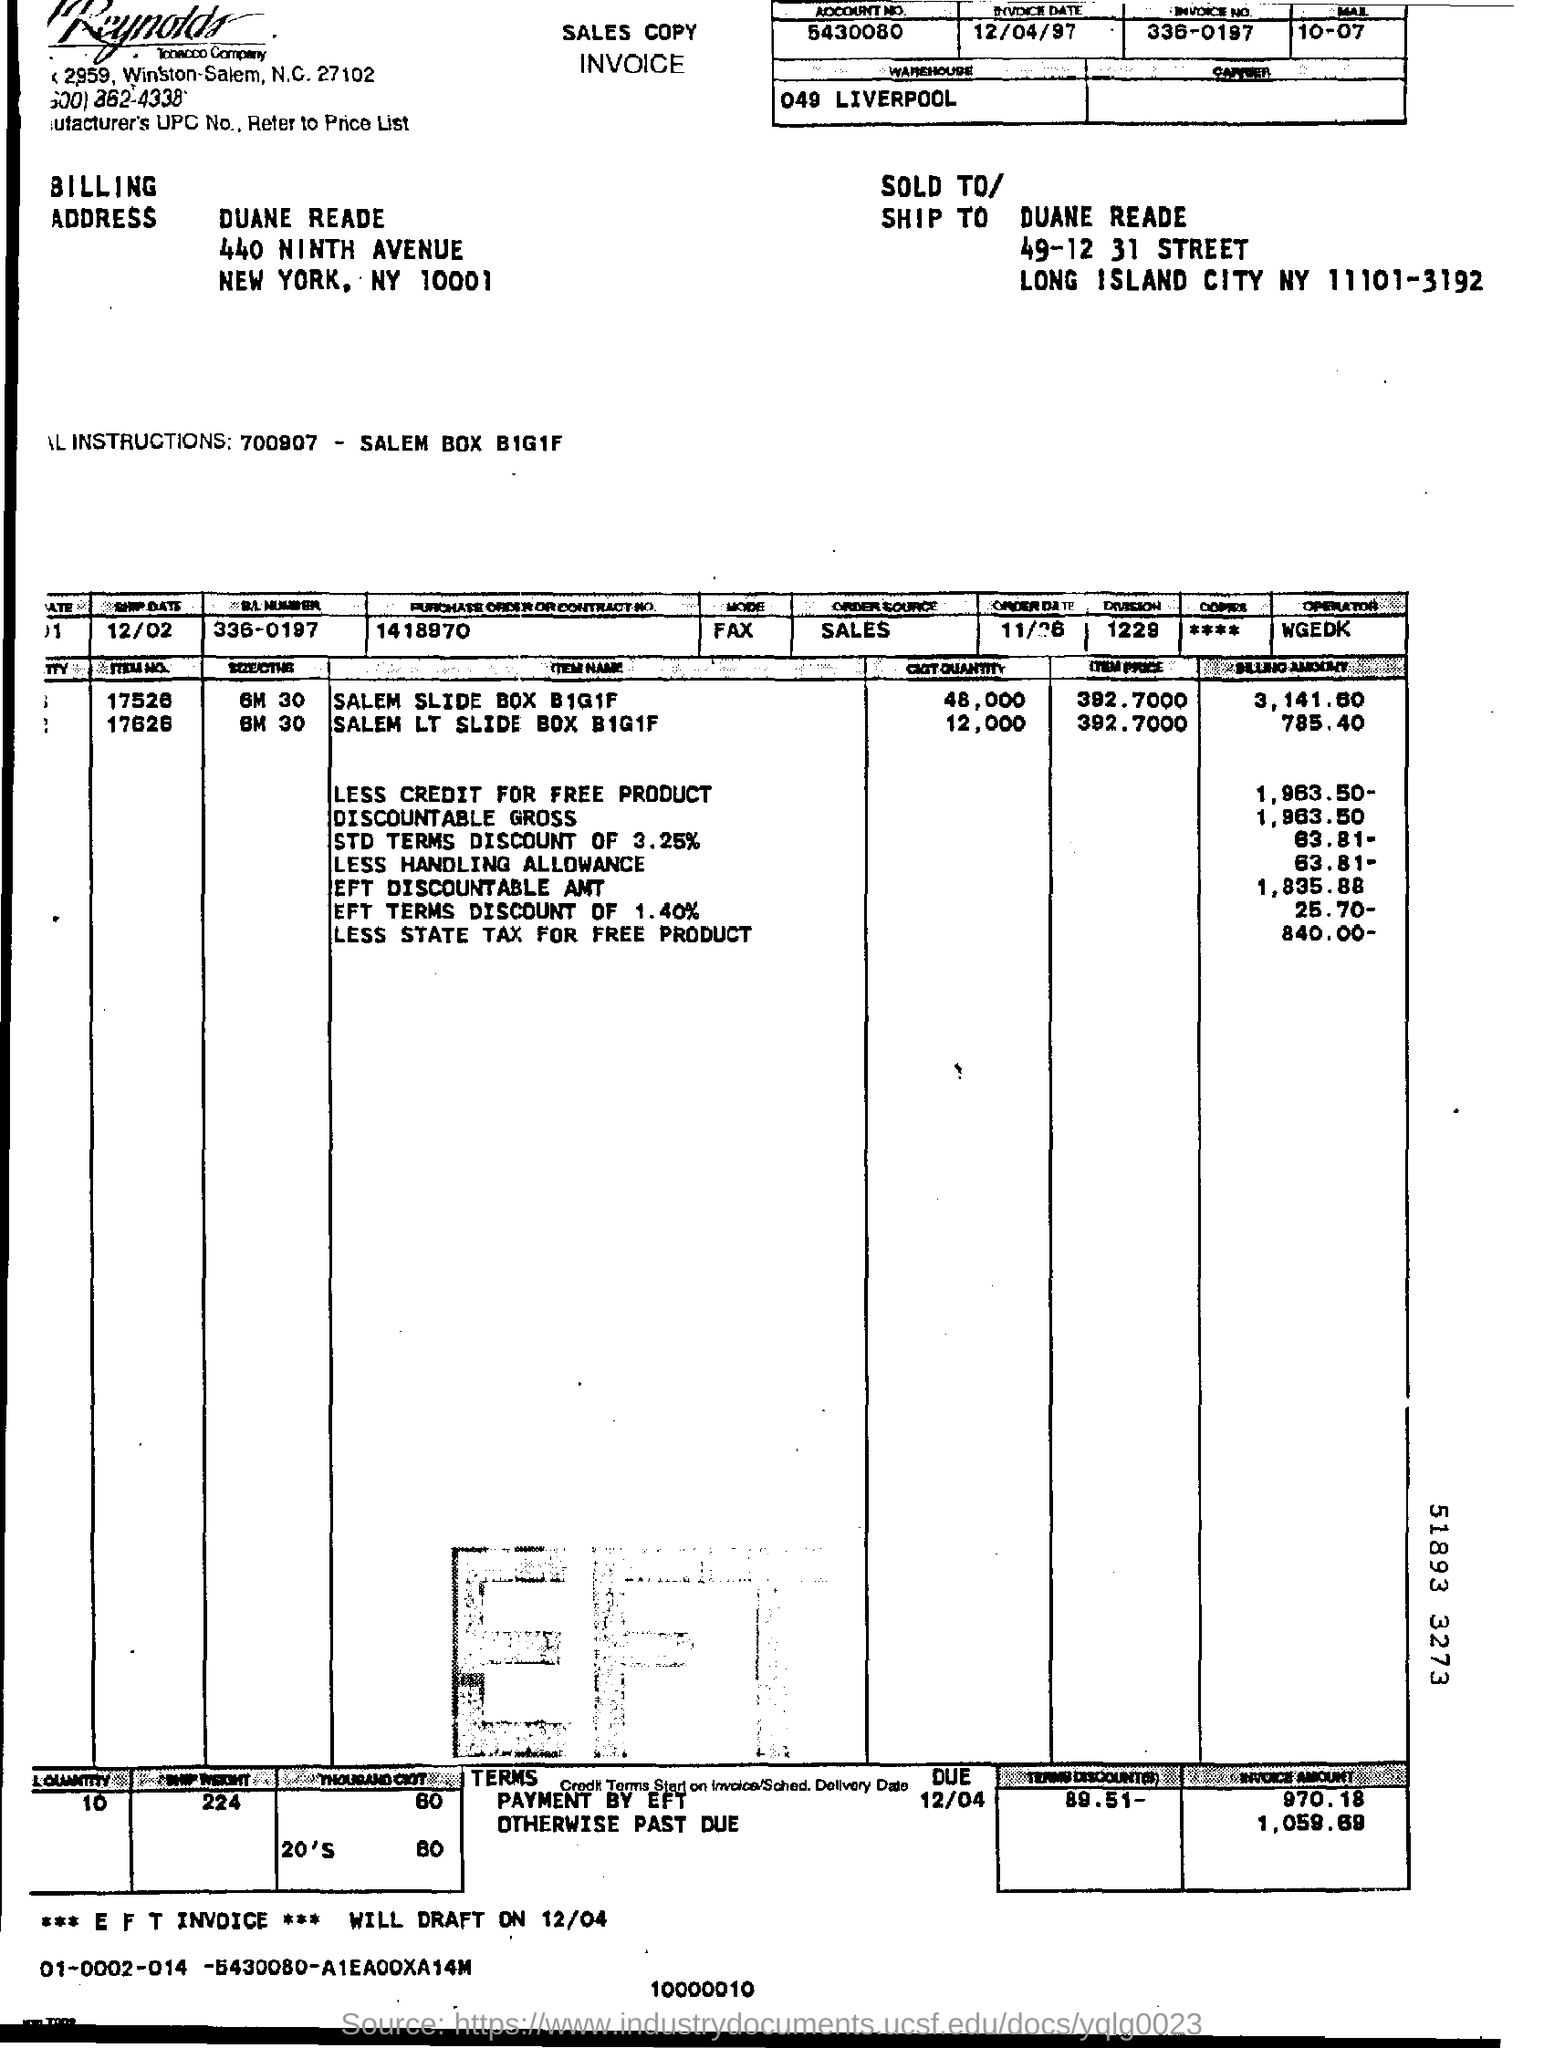What is the division number?
Make the answer very short. 1229. 